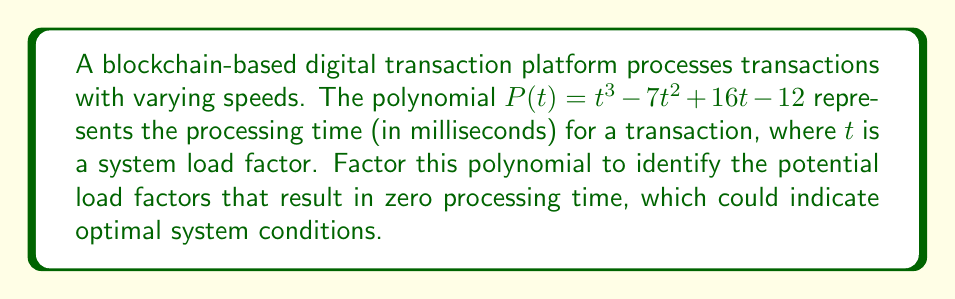Show me your answer to this math problem. To factor the polynomial $P(t) = t^3 - 7t^2 + 16t - 12$, we'll follow these steps:

1) First, let's check if there's a common factor. There isn't, so we proceed.

2) This is a cubic polynomial. Let's try to find a root by guessing factors of the constant term (-12). Possible factors are ±1, ±2, ±3, ±4, ±6, ±12.

3) Testing these values, we find that $P(1) = 1 - 7 + 16 - 12 = -2 \neq 0$, but $P(3) = 27 - 63 + 48 - 12 = 0$. So, $(t-3)$ is a factor.

4) We can now use polynomial long division to divide $P(t)$ by $(t-3)$:

   $$t^3 - 7t^2 + 16t - 12 = (t-3)(t^2 - 4t + 4) + 0$$

5) The quadratic factor $t^2 - 4t + 4$ can be factored further:
   
   $t^2 - 4t + 4 = (t-2)^2$

6) Therefore, the complete factorization is:

   $P(t) = (t-3)(t-2)^2$

This factorization reveals that the polynomial has roots at $t=3$ (single root) and $t=2$ (double root).
Answer: $(t-3)(t-2)^2$ 